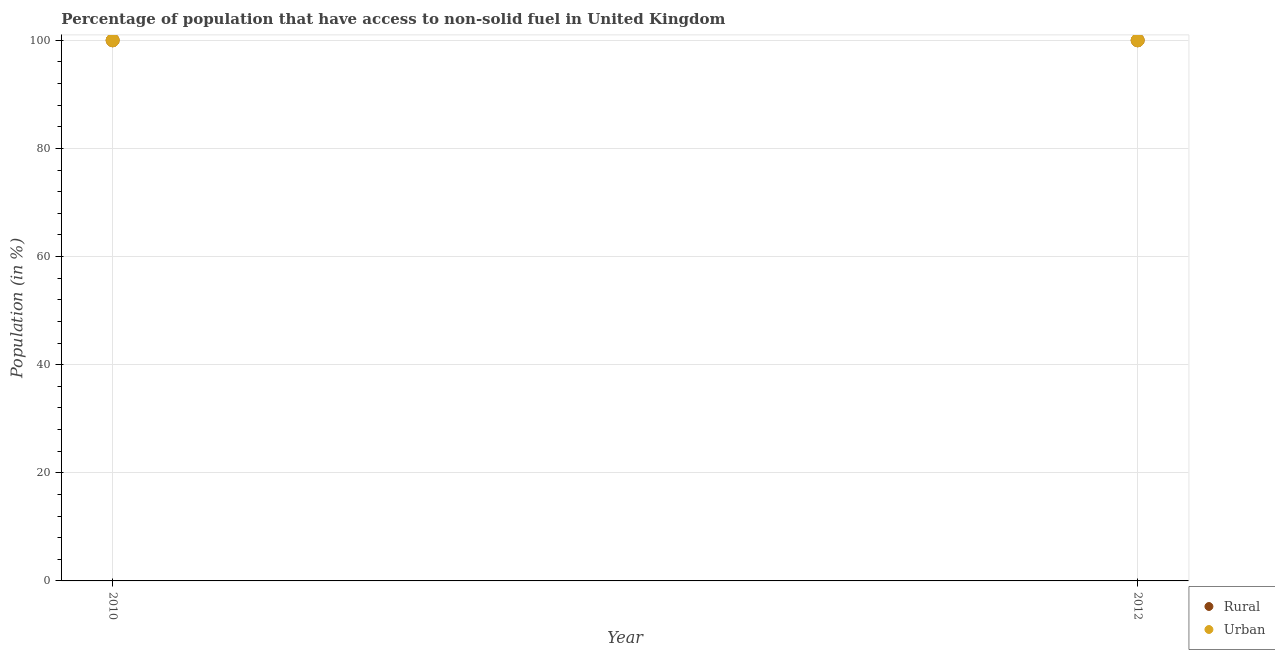How many different coloured dotlines are there?
Your response must be concise. 2. What is the urban population in 2010?
Your answer should be very brief. 100. Across all years, what is the maximum urban population?
Keep it short and to the point. 100. Across all years, what is the minimum rural population?
Keep it short and to the point. 100. In which year was the urban population maximum?
Provide a short and direct response. 2010. What is the total urban population in the graph?
Your answer should be compact. 200. In the year 2010, what is the difference between the rural population and urban population?
Offer a very short reply. 0. In how many years, is the rural population greater than 12 %?
Ensure brevity in your answer.  2. What is the ratio of the rural population in 2010 to that in 2012?
Keep it short and to the point. 1. Is the urban population in 2010 less than that in 2012?
Your response must be concise. No. How many dotlines are there?
Your answer should be compact. 2. Where does the legend appear in the graph?
Offer a very short reply. Bottom right. How many legend labels are there?
Provide a succinct answer. 2. How are the legend labels stacked?
Your answer should be compact. Vertical. What is the title of the graph?
Offer a terse response. Percentage of population that have access to non-solid fuel in United Kingdom. What is the label or title of the X-axis?
Provide a short and direct response. Year. What is the label or title of the Y-axis?
Ensure brevity in your answer.  Population (in %). What is the Population (in %) of Urban in 2010?
Offer a very short reply. 100. What is the Population (in %) of Urban in 2012?
Make the answer very short. 100. Across all years, what is the maximum Population (in %) of Rural?
Give a very brief answer. 100. Across all years, what is the maximum Population (in %) in Urban?
Your answer should be very brief. 100. Across all years, what is the minimum Population (in %) in Rural?
Ensure brevity in your answer.  100. Across all years, what is the minimum Population (in %) of Urban?
Keep it short and to the point. 100. What is the total Population (in %) in Rural in the graph?
Make the answer very short. 200. What is the difference between the Population (in %) of Rural in 2010 and that in 2012?
Provide a succinct answer. 0. What is the difference between the Population (in %) in Rural in 2010 and the Population (in %) in Urban in 2012?
Keep it short and to the point. 0. What is the average Population (in %) in Rural per year?
Provide a short and direct response. 100. What is the average Population (in %) of Urban per year?
Make the answer very short. 100. In the year 2010, what is the difference between the Population (in %) in Rural and Population (in %) in Urban?
Your answer should be very brief. 0. What is the ratio of the Population (in %) in Rural in 2010 to that in 2012?
Keep it short and to the point. 1. What is the ratio of the Population (in %) in Urban in 2010 to that in 2012?
Keep it short and to the point. 1. What is the difference between the highest and the second highest Population (in %) of Rural?
Provide a short and direct response. 0. What is the difference between the highest and the second highest Population (in %) in Urban?
Make the answer very short. 0. What is the difference between the highest and the lowest Population (in %) in Rural?
Ensure brevity in your answer.  0. What is the difference between the highest and the lowest Population (in %) in Urban?
Offer a very short reply. 0. 